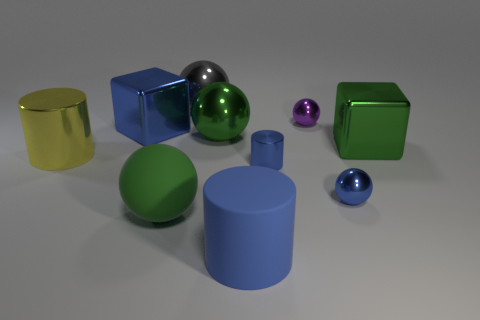Subtract all green metallic balls. How many balls are left? 4 Subtract 1 spheres. How many spheres are left? 4 Subtract all purple spheres. How many spheres are left? 4 Subtract all cylinders. How many objects are left? 7 Subtract all brown spheres. How many purple blocks are left? 0 Subtract all small brown metal things. Subtract all big green things. How many objects are left? 7 Add 5 green objects. How many green objects are left? 8 Add 6 tiny yellow matte objects. How many tiny yellow matte objects exist? 6 Subtract 1 blue blocks. How many objects are left? 9 Subtract all brown cubes. Subtract all green cylinders. How many cubes are left? 2 